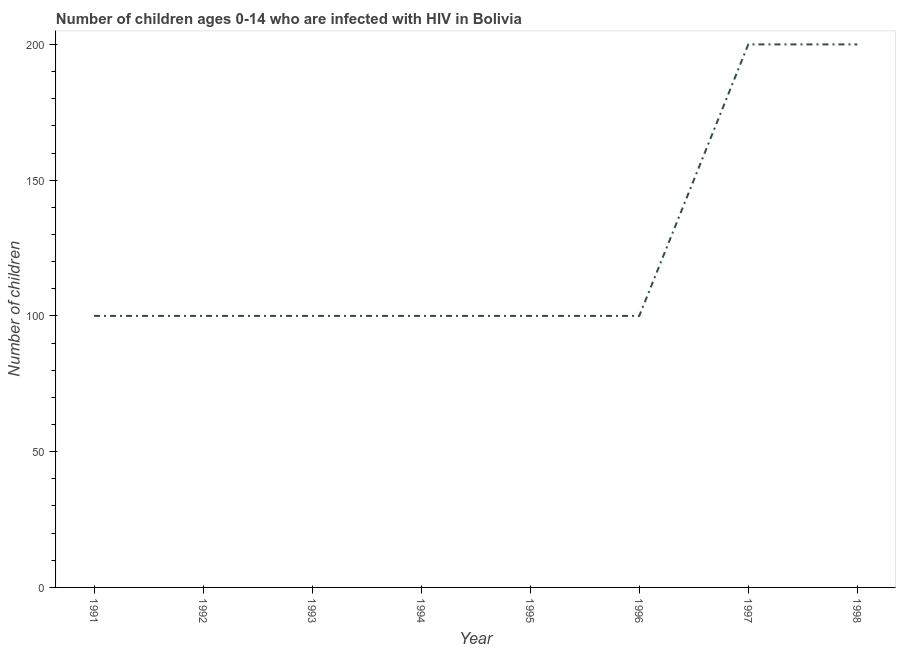What is the number of children living with hiv in 1991?
Keep it short and to the point. 100. Across all years, what is the maximum number of children living with hiv?
Provide a short and direct response. 200. Across all years, what is the minimum number of children living with hiv?
Ensure brevity in your answer.  100. In which year was the number of children living with hiv minimum?
Make the answer very short. 1991. What is the sum of the number of children living with hiv?
Your response must be concise. 1000. What is the difference between the number of children living with hiv in 1992 and 1998?
Ensure brevity in your answer.  -100. What is the average number of children living with hiv per year?
Keep it short and to the point. 125. Do a majority of the years between 1995 and 1991 (inclusive) have number of children living with hiv greater than 120 ?
Ensure brevity in your answer.  Yes. Is the number of children living with hiv in 1992 less than that in 1997?
Your answer should be very brief. Yes. What is the difference between the highest and the lowest number of children living with hiv?
Your answer should be very brief. 100. In how many years, is the number of children living with hiv greater than the average number of children living with hiv taken over all years?
Ensure brevity in your answer.  2. How many lines are there?
Offer a terse response. 1. How many years are there in the graph?
Your response must be concise. 8. What is the difference between two consecutive major ticks on the Y-axis?
Your answer should be very brief. 50. Are the values on the major ticks of Y-axis written in scientific E-notation?
Offer a terse response. No. Does the graph contain grids?
Keep it short and to the point. No. What is the title of the graph?
Provide a succinct answer. Number of children ages 0-14 who are infected with HIV in Bolivia. What is the label or title of the Y-axis?
Your answer should be compact. Number of children. What is the Number of children in 1991?
Ensure brevity in your answer.  100. What is the Number of children of 1992?
Your answer should be very brief. 100. What is the Number of children in 1993?
Keep it short and to the point. 100. What is the Number of children in 1996?
Keep it short and to the point. 100. What is the Number of children in 1998?
Your response must be concise. 200. What is the difference between the Number of children in 1991 and 1993?
Give a very brief answer. 0. What is the difference between the Number of children in 1991 and 1994?
Your answer should be very brief. 0. What is the difference between the Number of children in 1991 and 1996?
Provide a succinct answer. 0. What is the difference between the Number of children in 1991 and 1997?
Your response must be concise. -100. What is the difference between the Number of children in 1991 and 1998?
Offer a terse response. -100. What is the difference between the Number of children in 1992 and 1993?
Offer a terse response. 0. What is the difference between the Number of children in 1992 and 1994?
Provide a short and direct response. 0. What is the difference between the Number of children in 1992 and 1995?
Your answer should be very brief. 0. What is the difference between the Number of children in 1992 and 1996?
Your response must be concise. 0. What is the difference between the Number of children in 1992 and 1997?
Your response must be concise. -100. What is the difference between the Number of children in 1992 and 1998?
Provide a short and direct response. -100. What is the difference between the Number of children in 1993 and 1997?
Provide a short and direct response. -100. What is the difference between the Number of children in 1993 and 1998?
Ensure brevity in your answer.  -100. What is the difference between the Number of children in 1994 and 1995?
Make the answer very short. 0. What is the difference between the Number of children in 1994 and 1996?
Make the answer very short. 0. What is the difference between the Number of children in 1994 and 1997?
Keep it short and to the point. -100. What is the difference between the Number of children in 1994 and 1998?
Your answer should be very brief. -100. What is the difference between the Number of children in 1995 and 1996?
Make the answer very short. 0. What is the difference between the Number of children in 1995 and 1997?
Provide a succinct answer. -100. What is the difference between the Number of children in 1995 and 1998?
Ensure brevity in your answer.  -100. What is the difference between the Number of children in 1996 and 1997?
Your answer should be very brief. -100. What is the difference between the Number of children in 1996 and 1998?
Offer a very short reply. -100. What is the ratio of the Number of children in 1991 to that in 1996?
Offer a terse response. 1. What is the ratio of the Number of children in 1992 to that in 1993?
Your answer should be very brief. 1. What is the ratio of the Number of children in 1992 to that in 1994?
Make the answer very short. 1. What is the ratio of the Number of children in 1992 to that in 1995?
Keep it short and to the point. 1. What is the ratio of the Number of children in 1992 to that in 1997?
Your answer should be very brief. 0.5. What is the ratio of the Number of children in 1992 to that in 1998?
Give a very brief answer. 0.5. What is the ratio of the Number of children in 1993 to that in 1994?
Offer a very short reply. 1. What is the ratio of the Number of children in 1993 to that in 1996?
Offer a terse response. 1. What is the ratio of the Number of children in 1993 to that in 1997?
Give a very brief answer. 0.5. What is the ratio of the Number of children in 1993 to that in 1998?
Provide a succinct answer. 0.5. What is the ratio of the Number of children in 1994 to that in 1995?
Your answer should be compact. 1. What is the ratio of the Number of children in 1994 to that in 1996?
Make the answer very short. 1. What is the ratio of the Number of children in 1995 to that in 1998?
Offer a terse response. 0.5. What is the ratio of the Number of children in 1996 to that in 1997?
Your answer should be very brief. 0.5. What is the ratio of the Number of children in 1996 to that in 1998?
Your response must be concise. 0.5. 